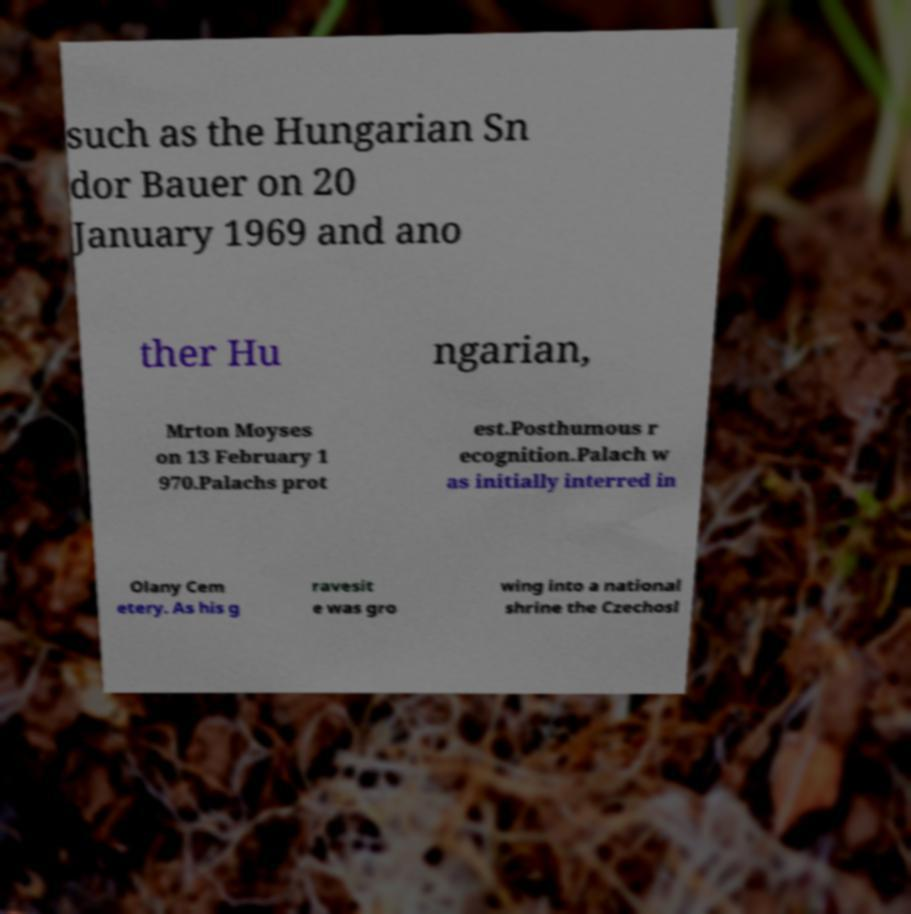Could you extract and type out the text from this image? such as the Hungarian Sn dor Bauer on 20 January 1969 and ano ther Hu ngarian, Mrton Moyses on 13 February 1 970.Palachs prot est.Posthumous r ecognition.Palach w as initially interred in Olany Cem etery. As his g ravesit e was gro wing into a national shrine the Czechosl 